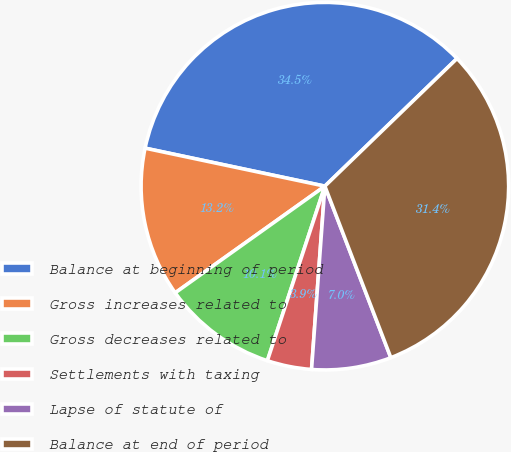Convert chart to OTSL. <chart><loc_0><loc_0><loc_500><loc_500><pie_chart><fcel>Balance at beginning of period<fcel>Gross increases related to<fcel>Gross decreases related to<fcel>Settlements with taxing<fcel>Lapse of statute of<fcel>Balance at end of period<nl><fcel>34.46%<fcel>13.17%<fcel>10.08%<fcel>3.91%<fcel>7.0%<fcel>31.38%<nl></chart> 